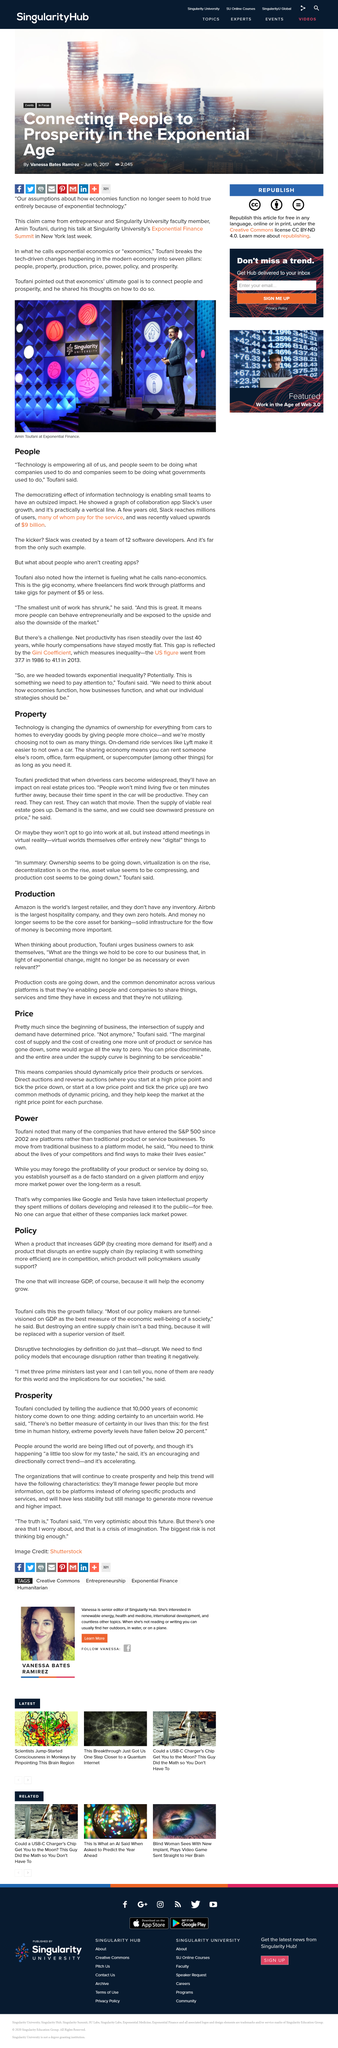Draw attention to some important aspects in this diagram. Toufani stated that technology is empowering all of us and that the internet is fueling nano-economics. The benefits of driverless cars are that individuals can utilize the time spent in their vehicle to be productive. We can reduce costs by sharing resources such as things, services, and time. In my opinion, production is more important than ideas. Slack provides a paid service that is used by many individuals and organizations who voluntarily pay for its use. 